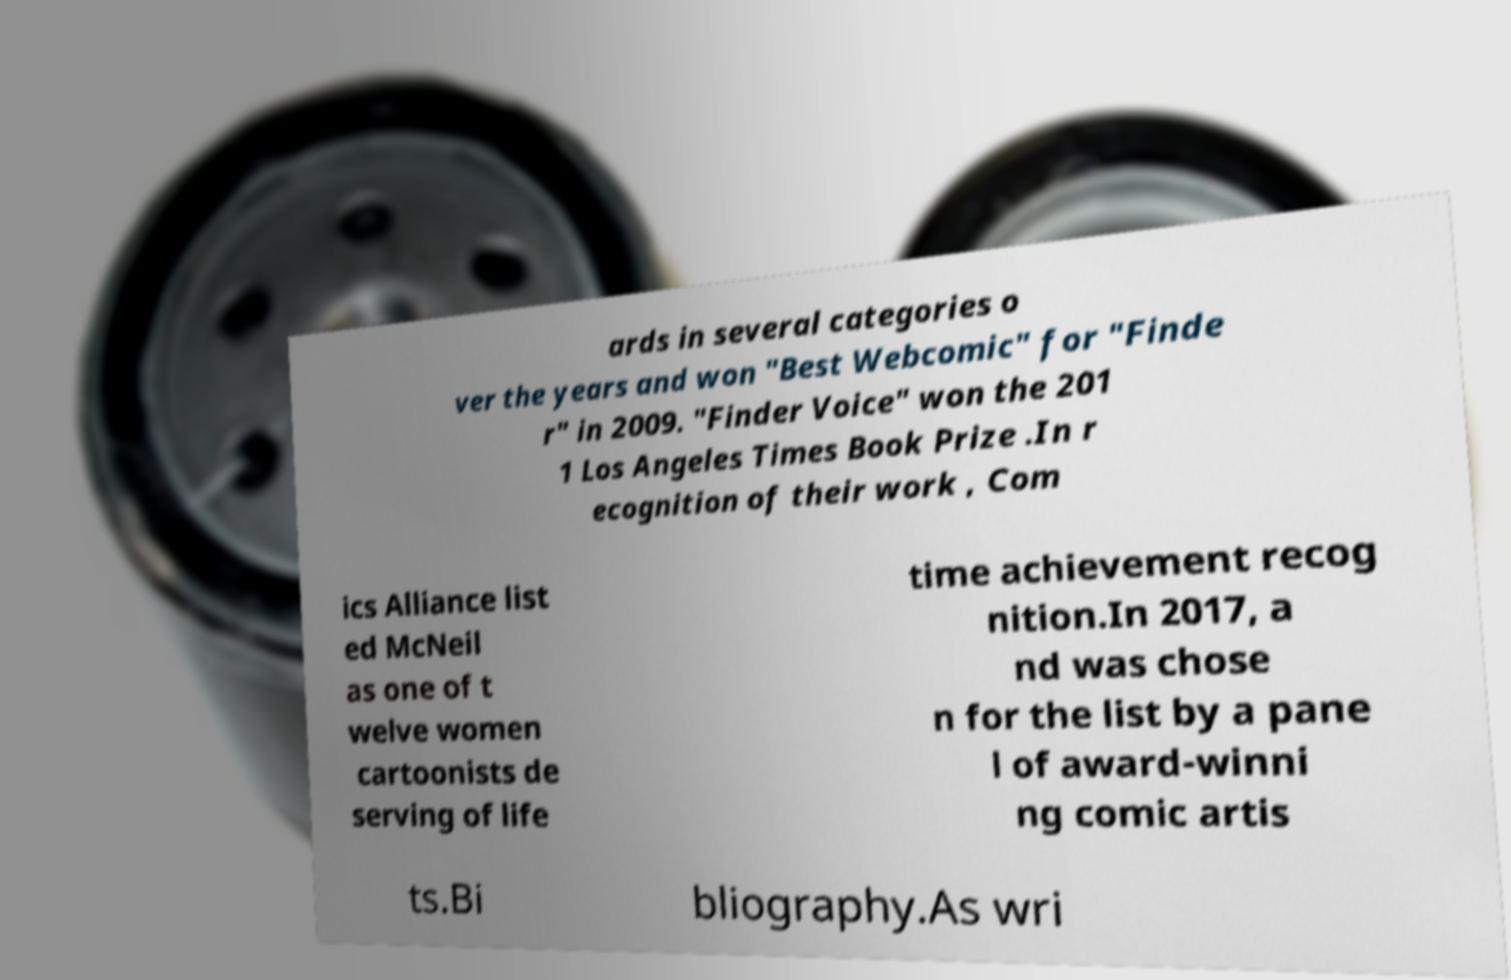There's text embedded in this image that I need extracted. Can you transcribe it verbatim? ards in several categories o ver the years and won "Best Webcomic" for "Finde r" in 2009. "Finder Voice" won the 201 1 Los Angeles Times Book Prize .In r ecognition of their work , Com ics Alliance list ed McNeil as one of t welve women cartoonists de serving of life time achievement recog nition.In 2017, a nd was chose n for the list by a pane l of award-winni ng comic artis ts.Bi bliography.As wri 